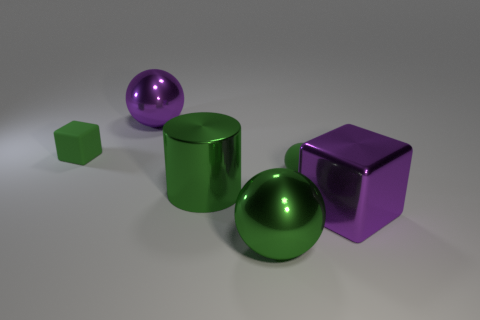Could you elaborate on the lighting and the shadows produced by the objects? Certainly! The image features a soft, diffused lighting that casts gentle shadows beneath each object, slightly to the left. The light source appears to be above and to the right, as indicated by the highlight on the objects and their shadows' orientation. This lighting enhances the three-dimensional effect, highlighting the curvature of the spheres and the angles of the cubes. 